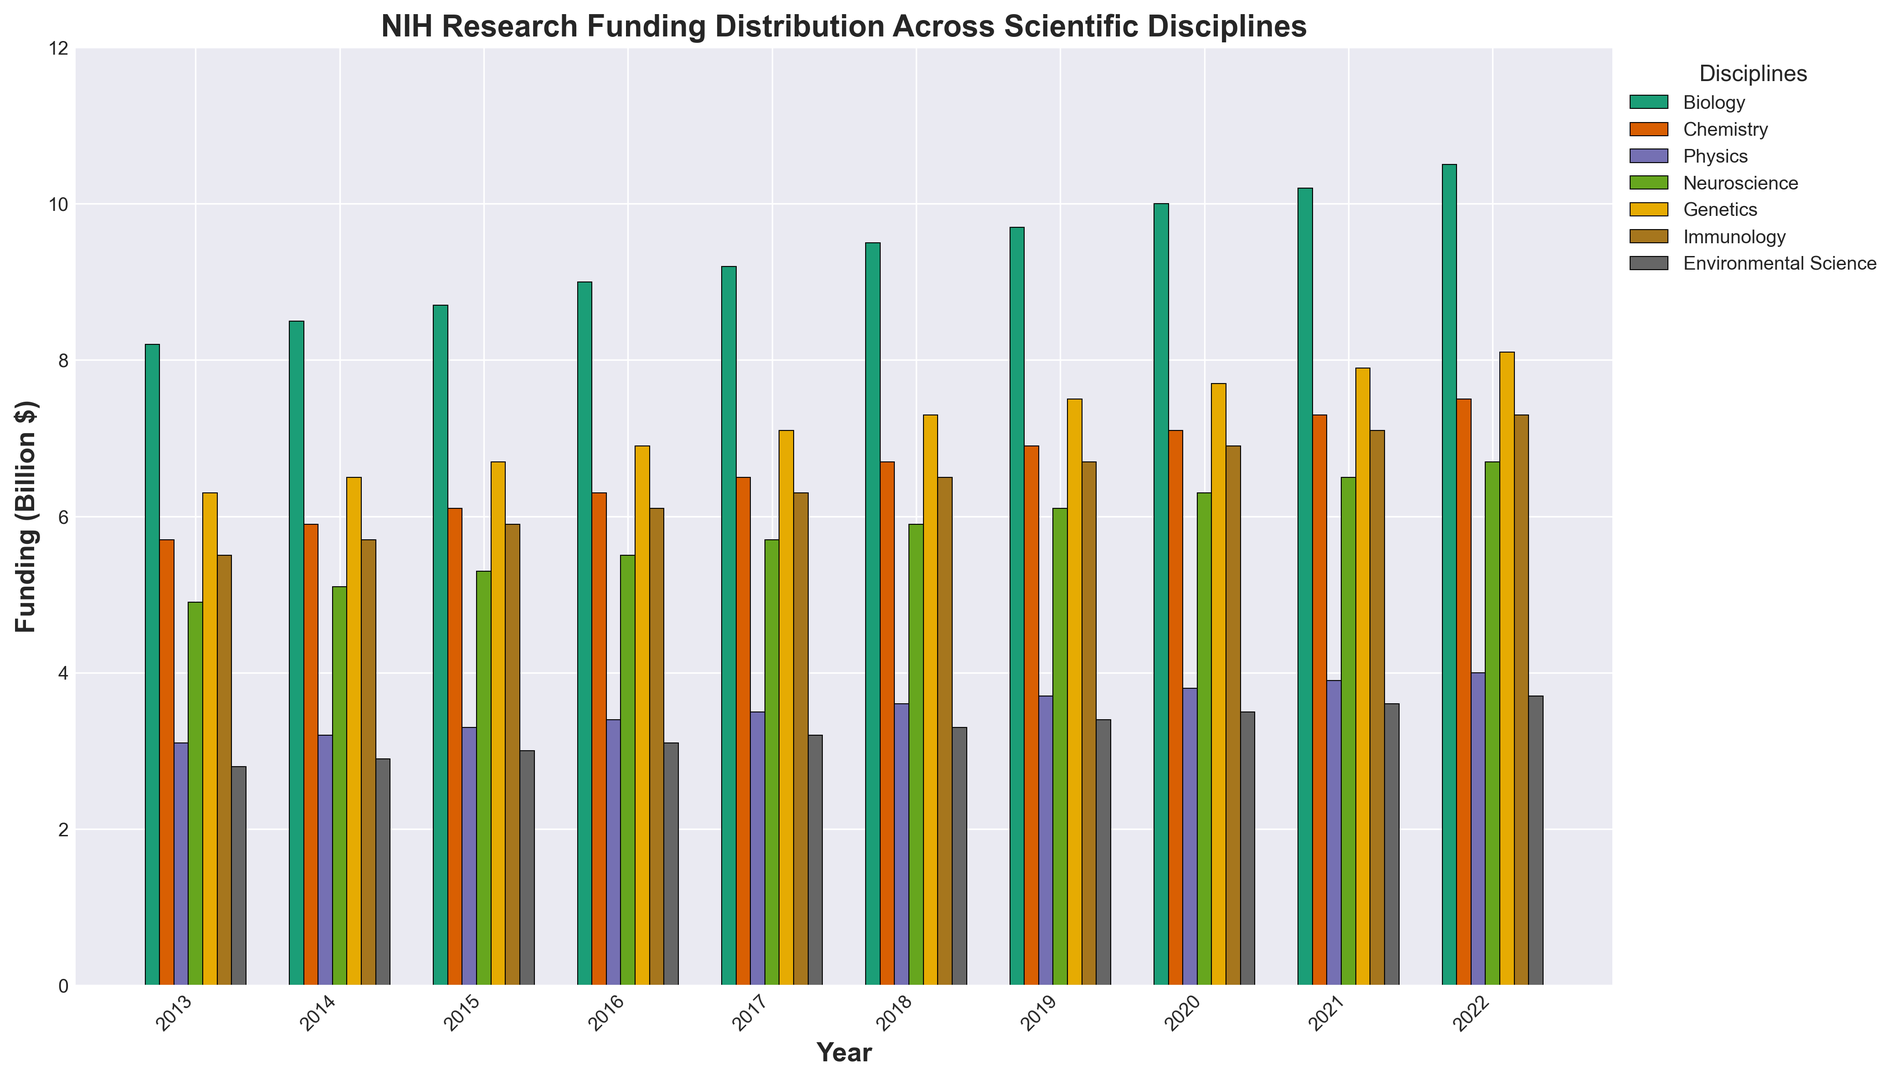Which year had the highest funding in Biology? Looking at the bar heights for Biology (typically the first bars in each group), the highest one is in 2022.
Answer: 2022 What was the difference in funding for Physics between 2013 and 2022? The funding for Physics in 2013 is 3.1 billion dollars, and in 2022, it’s 4.0 billion dollars. The difference is 4.0 - 3.1 = 0.9 billion dollars.
Answer: 0.9 billion dollars On average, how much funding did Neuroscience receive annually from 2013 to 2022? The yearly funding amounts for Neuroscience are: 4.9, 5.1, 5.3, 5.5, 5.7, 5.9, 6.1, 6.3, 6.5, 6.7. Summing these: 4.9 + 5.1 + 5.3 + 5.5 + 5.7 + 5.9 + 6.1 + 6.3 + 6.5 + 6.7 = 57.0. The average is 57.0 / 10 = 5.7 billion dollars.
Answer: 5.7 billion dollars Which discipline has the most consistent funding (smallest variation) over the years? To determine this, we can observe the relative uniformity in bar heights over the years. Physics bars appear to change the least, indicating the most consistent funding.
Answer: Physics How does the funding for Genetics in 2022 compare to Immunology in the same year? In 2022, the bar for Genetics is at 8.1 billion dollars, and for Immunology, it’s 7.3 billion dollars. Genetics has higher funding.
Answer: Genetics Which two disciplines had the closest funding values in 2016? Looking at the bar heights in 2016, Chemistry and Genetics seem very close. Checking the values, Chemistry is 6.3 billion dollars and Genetics is 6.9 billion dollars with a difference of 0.6 billion dollars.
Answer: Chemistry and Genetics How did the funding for Environmental Science change from the beginning to the end of the period? At the beginning in 2013, the funding was 2.8 billion dollars, and at the end in 2022, it was 3.7 billion dollars. The change is 3.7 - 2.8 = 0.9 billion dollars.
Answer: Increased by 0.9 billion dollars In which year did Chemistry first reach or exceed 7 billion dollars in funding? Observing the bar heights for Chemistry, the bar first reaches 7 billion dollars in 2020.
Answer: 2020 